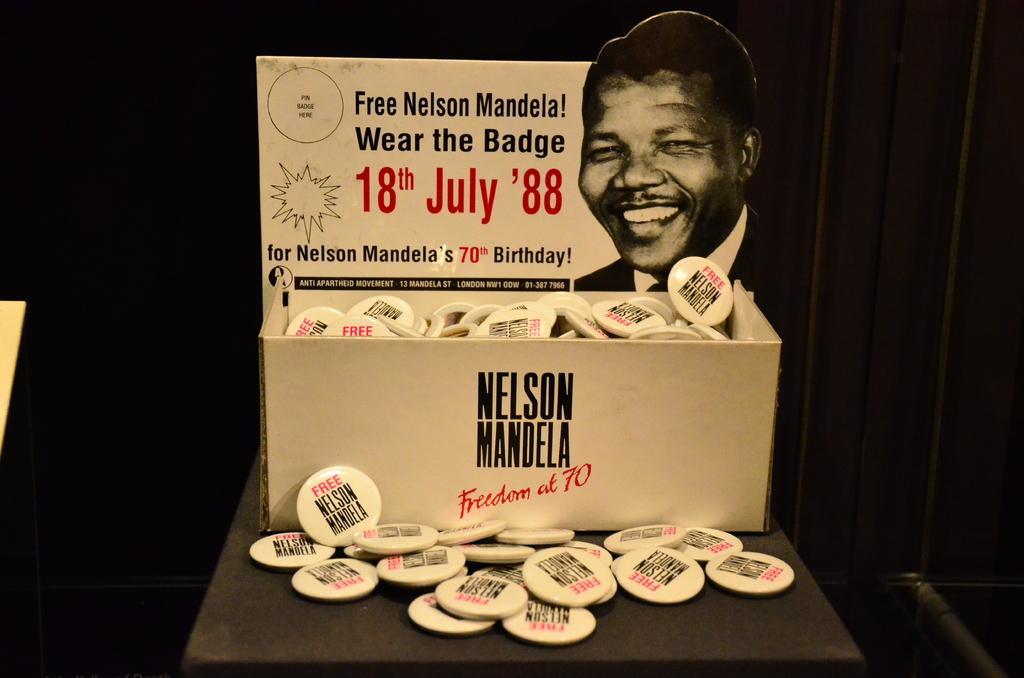Could you give a brief overview of what you see in this image? In the picture there are a lot of badges of Nelson Mandela kept in a box and the background of the box is in black color. 